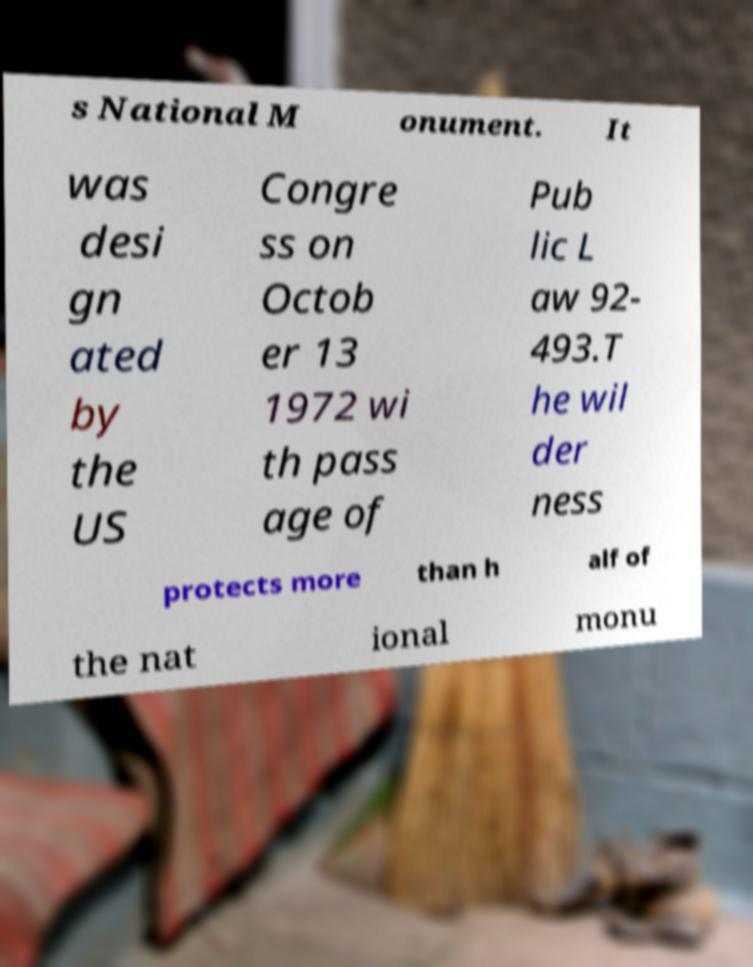What messages or text are displayed in this image? I need them in a readable, typed format. s National M onument. It was desi gn ated by the US Congre ss on Octob er 13 1972 wi th pass age of Pub lic L aw 92- 493.T he wil der ness protects more than h alf of the nat ional monu 